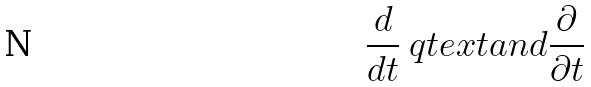Convert formula to latex. <formula><loc_0><loc_0><loc_500><loc_500>\frac { d } { d t } \ q t e x t { a n d } \frac { \partial } { \partial t }</formula> 